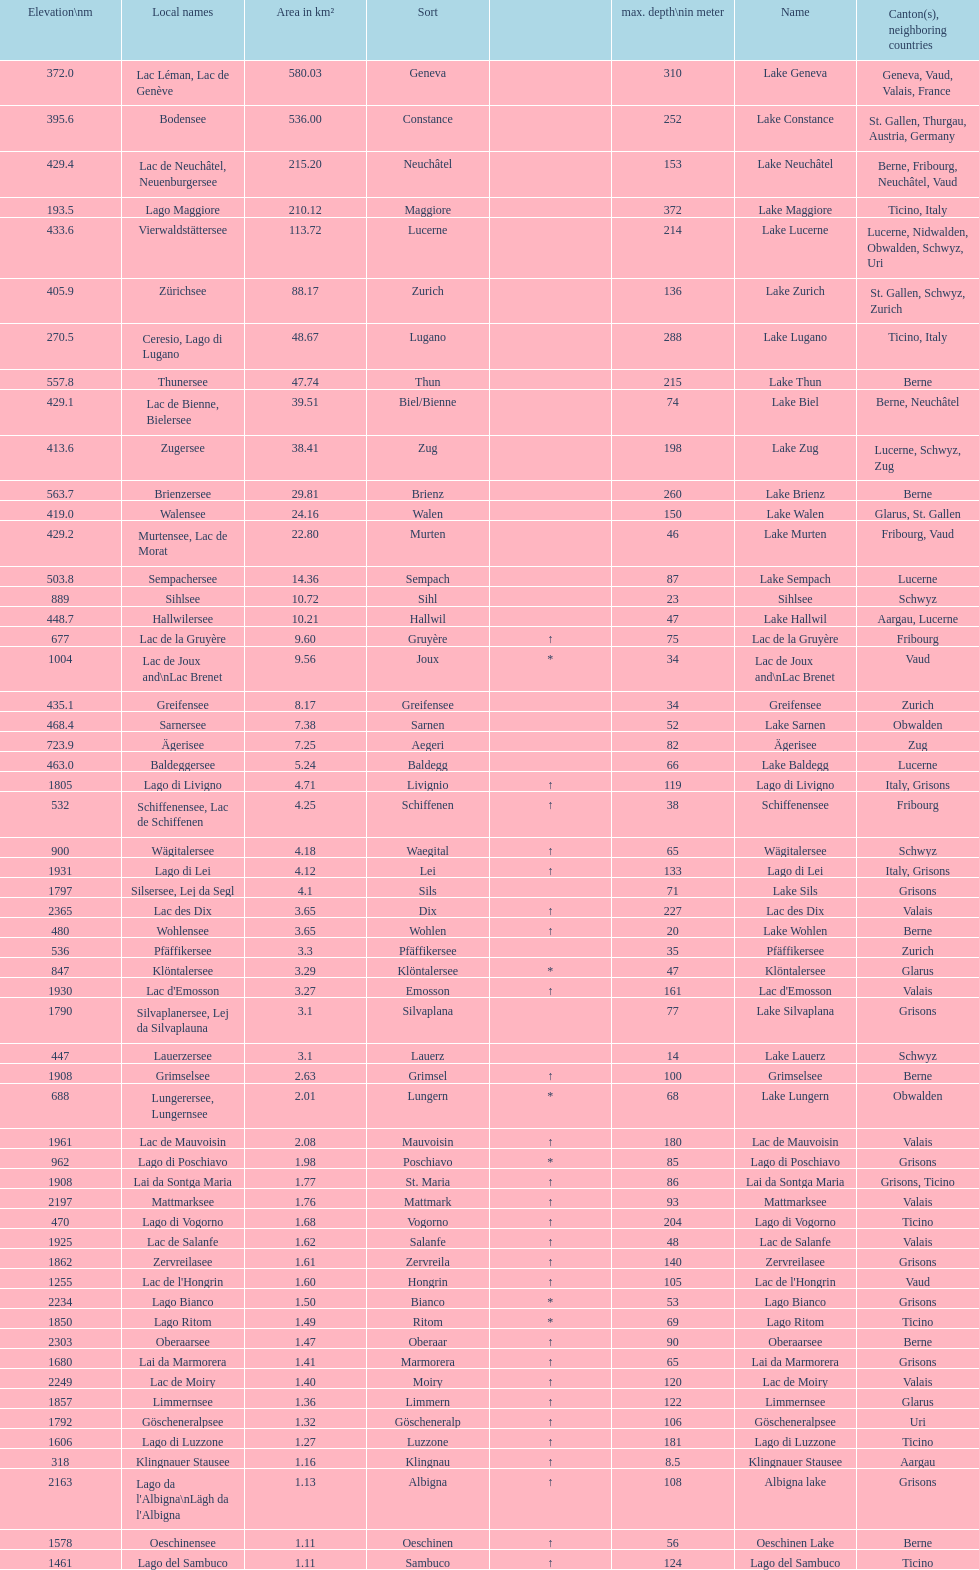How many lakes are there with an area smaller than 100 square kilometers? 51. 